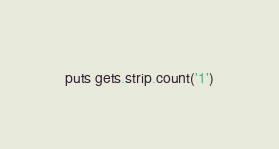<code> <loc_0><loc_0><loc_500><loc_500><_Ruby_>puts gets.strip.count('1')</code> 